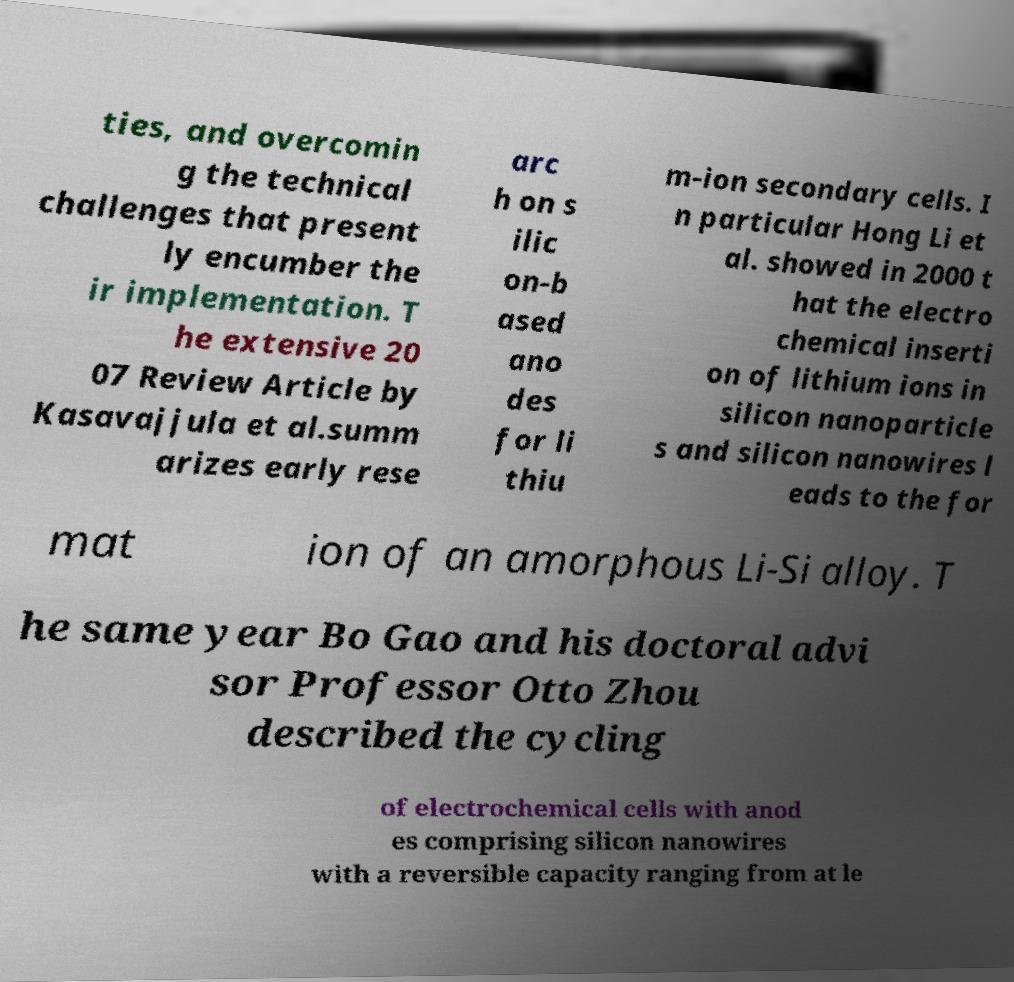Could you extract and type out the text from this image? ties, and overcomin g the technical challenges that present ly encumber the ir implementation. T he extensive 20 07 Review Article by Kasavajjula et al.summ arizes early rese arc h on s ilic on-b ased ano des for li thiu m-ion secondary cells. I n particular Hong Li et al. showed in 2000 t hat the electro chemical inserti on of lithium ions in silicon nanoparticle s and silicon nanowires l eads to the for mat ion of an amorphous Li-Si alloy. T he same year Bo Gao and his doctoral advi sor Professor Otto Zhou described the cycling of electrochemical cells with anod es comprising silicon nanowires with a reversible capacity ranging from at le 